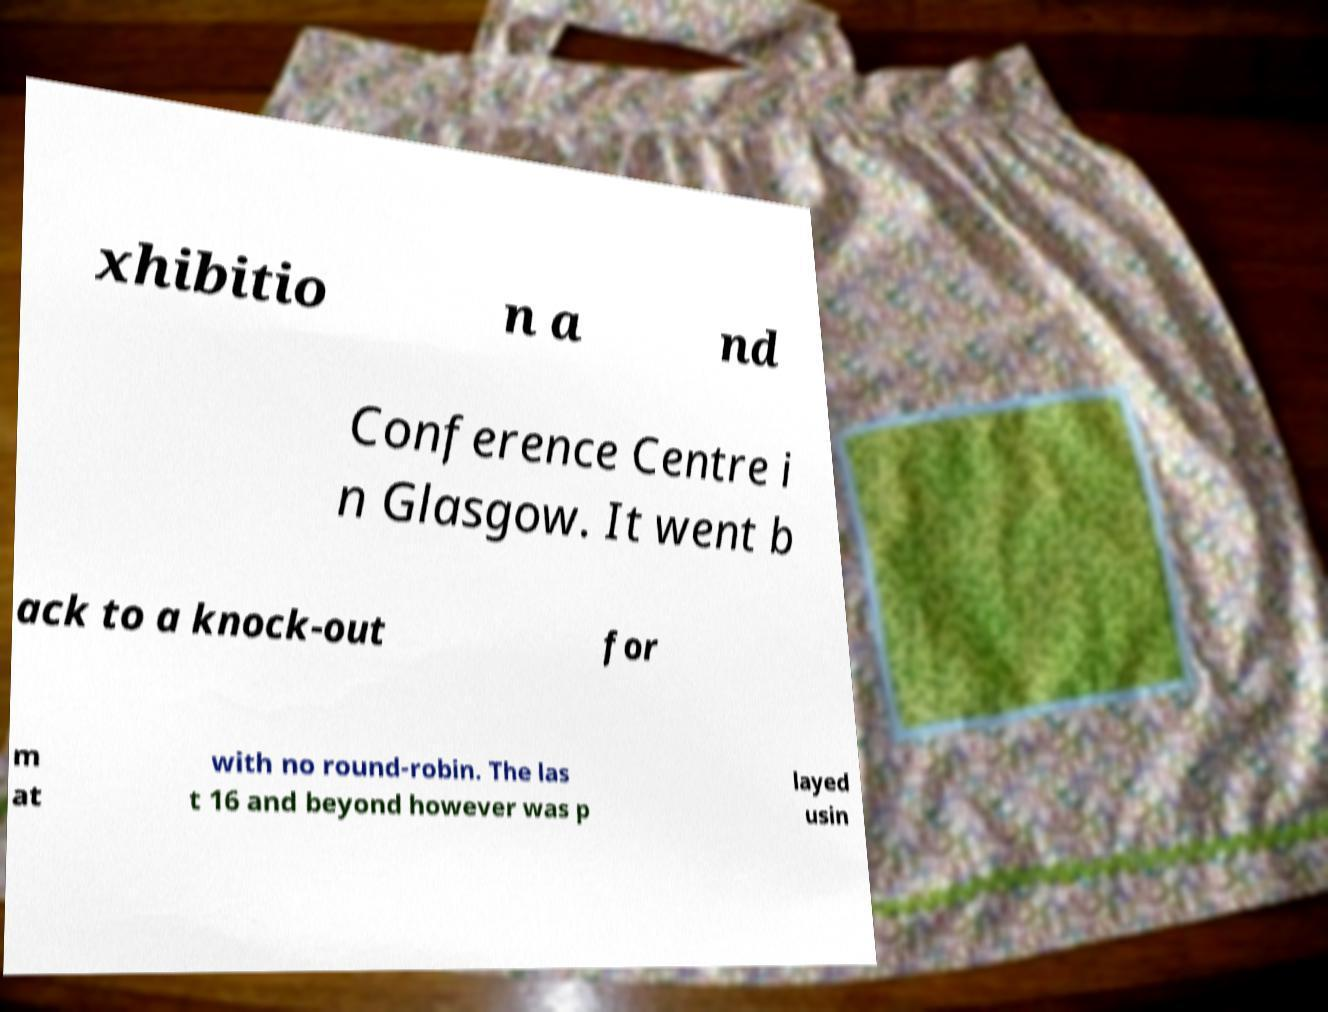Could you extract and type out the text from this image? xhibitio n a nd Conference Centre i n Glasgow. It went b ack to a knock-out for m at with no round-robin. The las t 16 and beyond however was p layed usin 